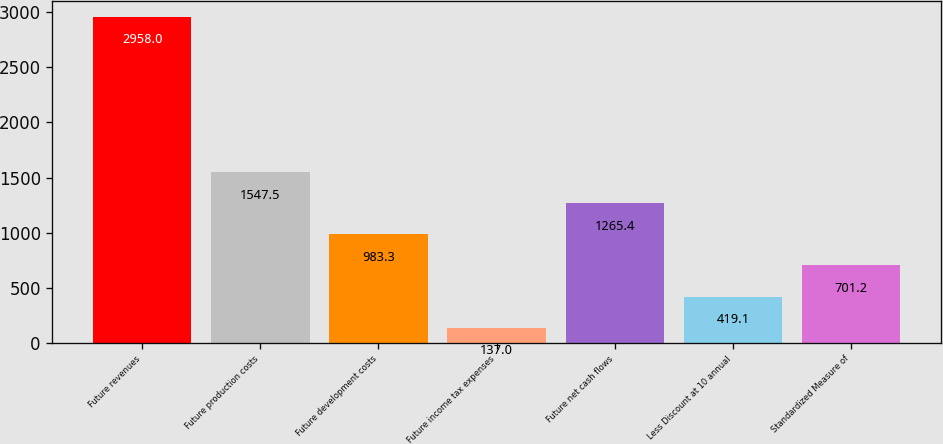Convert chart to OTSL. <chart><loc_0><loc_0><loc_500><loc_500><bar_chart><fcel>Future revenues<fcel>Future production costs<fcel>Future development costs<fcel>Future income tax expenses<fcel>Future net cash flows<fcel>Less Discount at 10 annual<fcel>Standardized Measure of<nl><fcel>2958<fcel>1547.5<fcel>983.3<fcel>137<fcel>1265.4<fcel>419.1<fcel>701.2<nl></chart> 